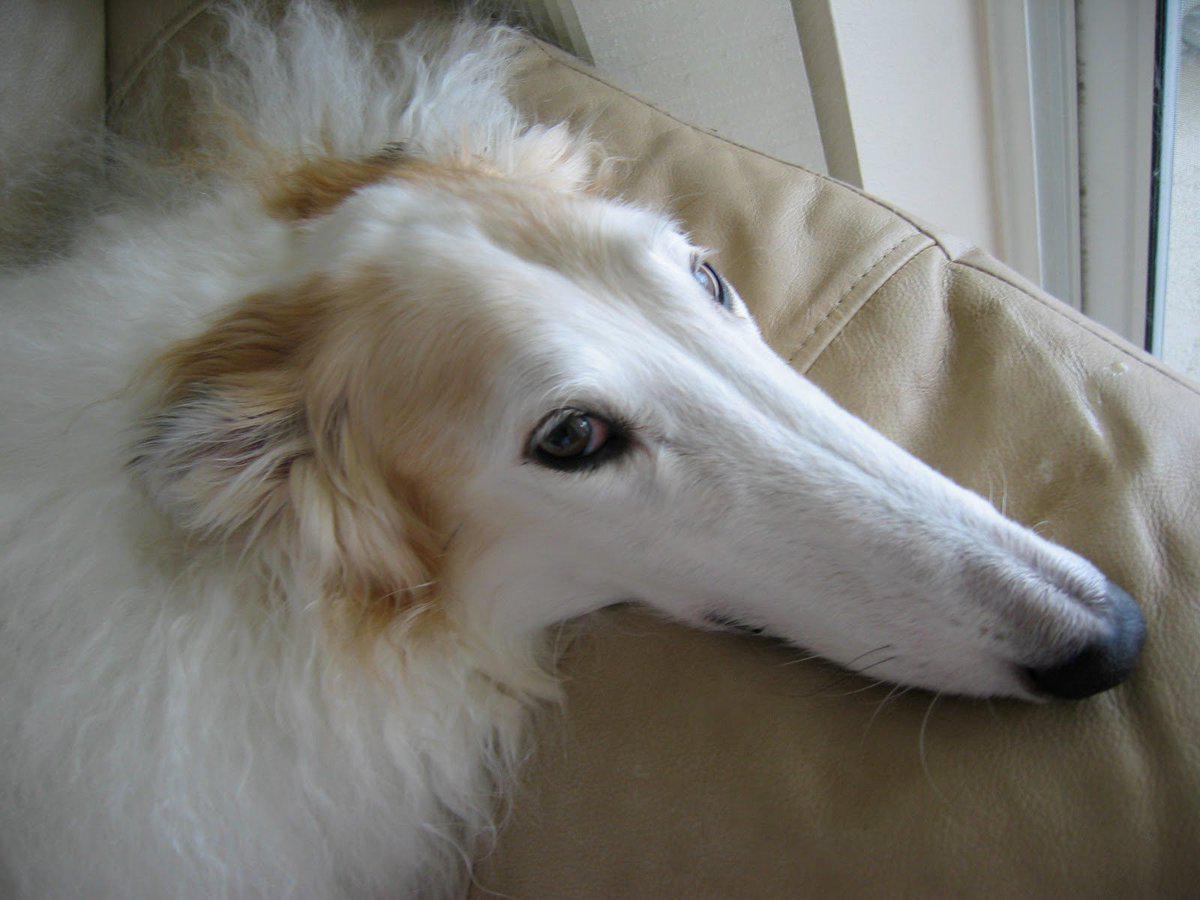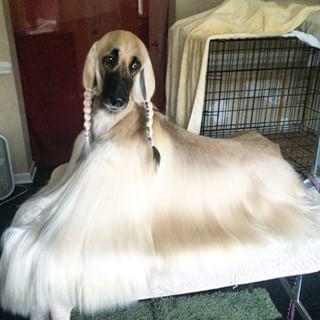The first image is the image on the left, the second image is the image on the right. Given the left and right images, does the statement "At least one of the dogs is standing up outside in the grass." hold true? Answer yes or no. No. The first image is the image on the left, the second image is the image on the right. Evaluate the accuracy of this statement regarding the images: "At least one afghan hound with a curled upright tail is standing in profile.". Is it true? Answer yes or no. No. 